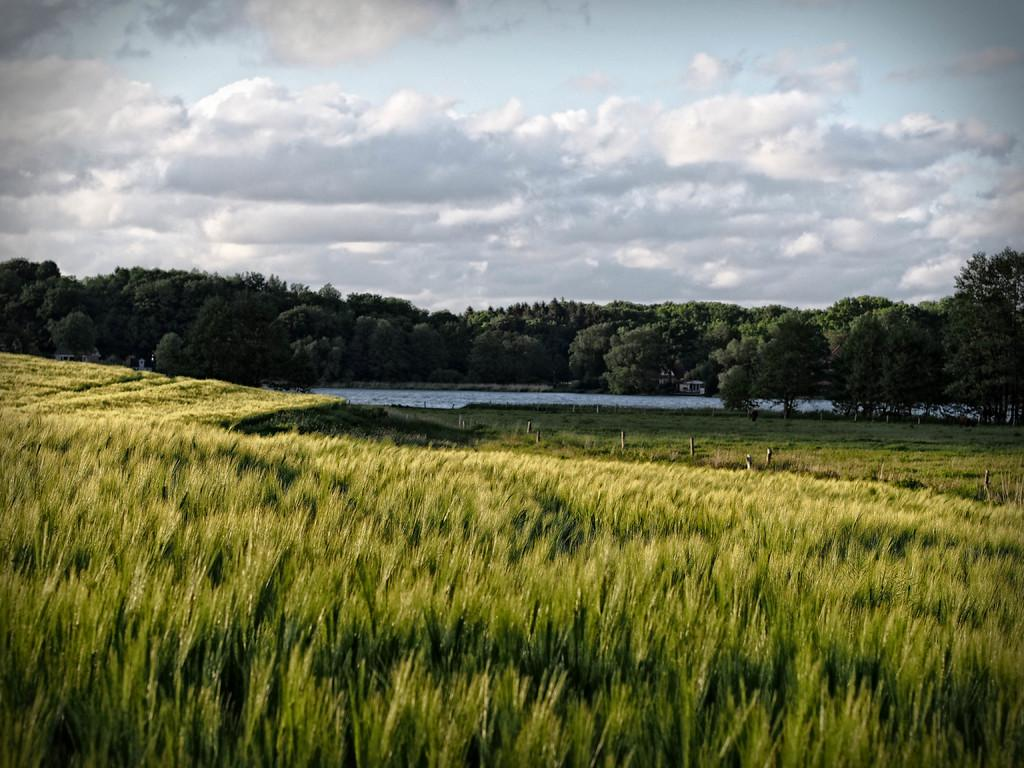Where was the picture taken? The picture was taken outside. What can be seen at the bottom of the image? There is a field at the bottom of the image. What is located in the center of the image? There is a river in the center of the image. What type of vegetation is near the river? There are trees beside the river. What is visible at the top of the image? The sky is visible at the top of the image. What can be observed in the sky? Clouds are present in the sky. What type of mitten is being used to catch the cord that is falling from the sky? There is no mitten or cord present in the image; it features a field, river, trees, and sky. 